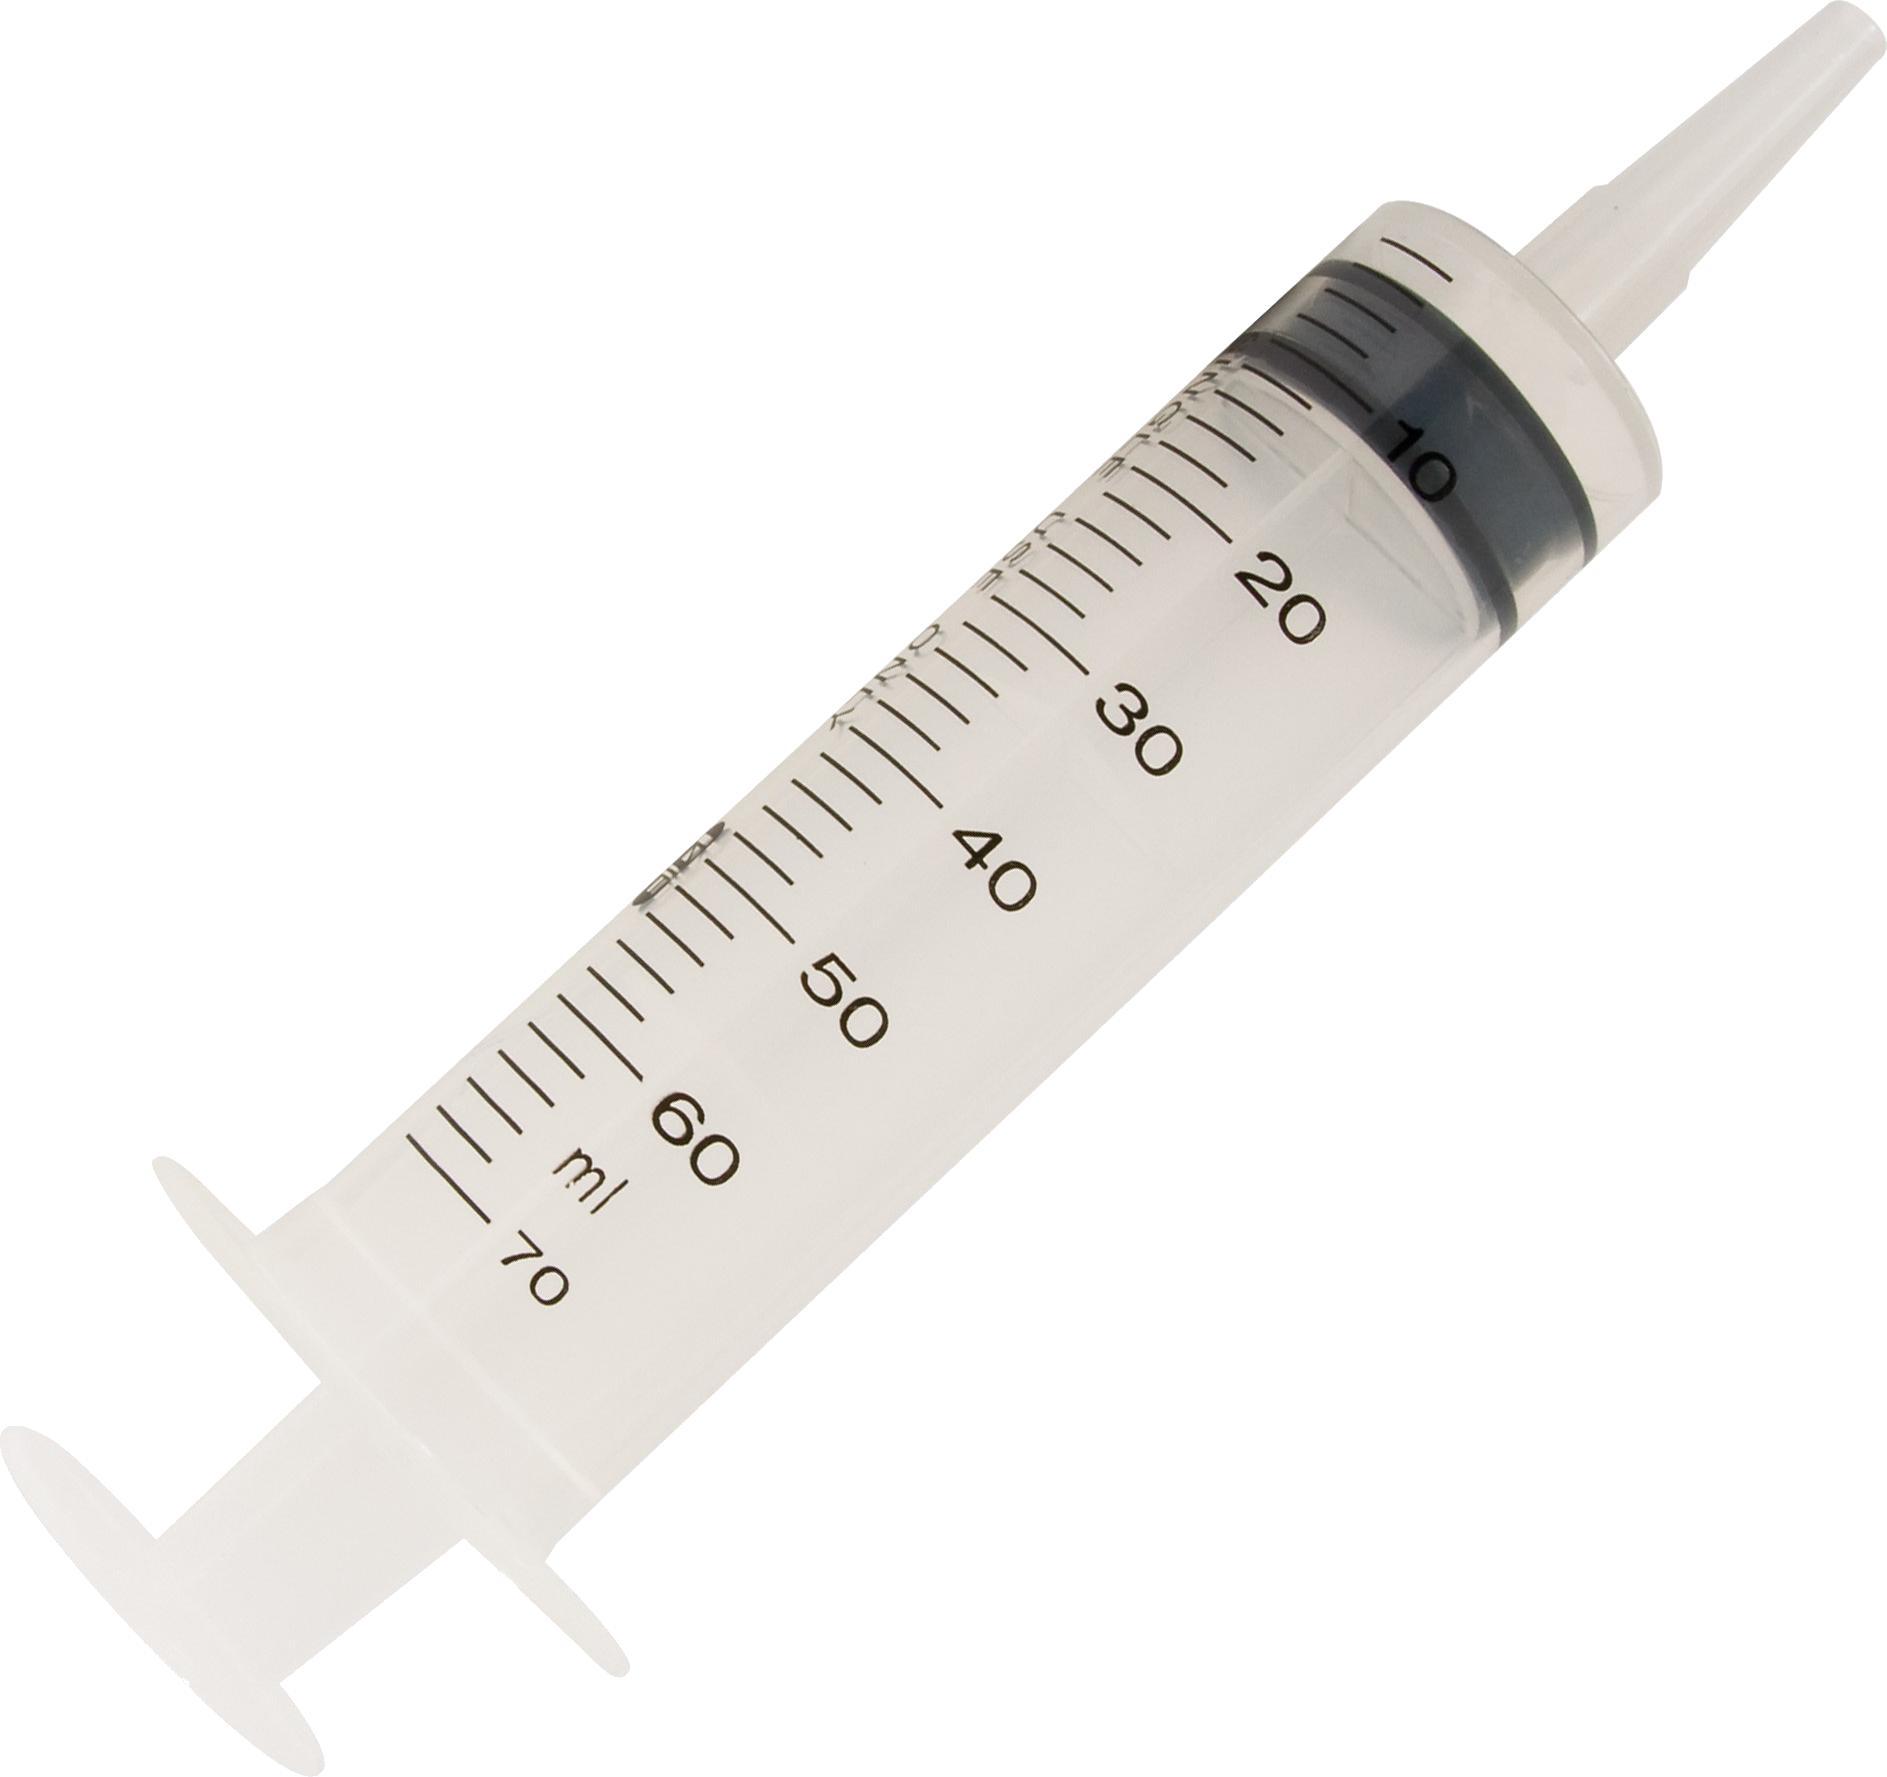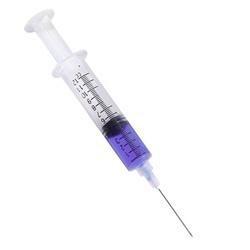The first image is the image on the left, the second image is the image on the right. Considering the images on both sides, is "Each image shows exactly one syringe, displayed at an angle." valid? Answer yes or no. Yes. The first image is the image on the left, the second image is the image on the right. Given the left and right images, does the statement "Each image shows only a single syringe." hold true? Answer yes or no. Yes. 